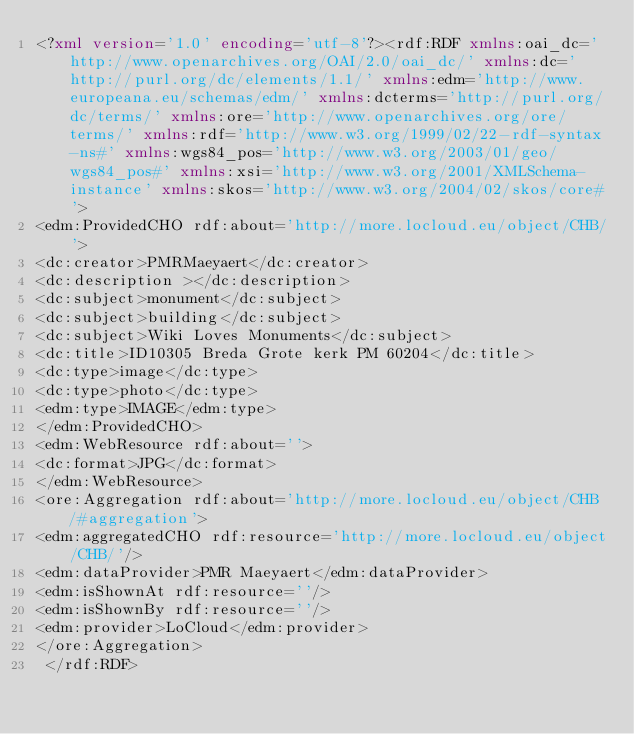Convert code to text. <code><loc_0><loc_0><loc_500><loc_500><_XML_><?xml version='1.0' encoding='utf-8'?><rdf:RDF xmlns:oai_dc='http://www.openarchives.org/OAI/2.0/oai_dc/' xmlns:dc='http://purl.org/dc/elements/1.1/' xmlns:edm='http://www.europeana.eu/schemas/edm/' xmlns:dcterms='http://purl.org/dc/terms/' xmlns:ore='http://www.openarchives.org/ore/terms/' xmlns:rdf='http://www.w3.org/1999/02/22-rdf-syntax-ns#' xmlns:wgs84_pos='http://www.w3.org/2003/01/geo/wgs84_pos#' xmlns:xsi='http://www.w3.org/2001/XMLSchema-instance' xmlns:skos='http://www.w3.org/2004/02/skos/core#'>
<edm:ProvidedCHO rdf:about='http://more.locloud.eu/object/CHB/'>
<dc:creator>PMRMaeyaert</dc:creator>
<dc:description ></dc:description>
<dc:subject>monument</dc:subject>
<dc:subject>building</dc:subject>
<dc:subject>Wiki Loves Monuments</dc:subject>
<dc:title>ID10305 Breda Grote kerk PM 60204</dc:title>
<dc:type>image</dc:type>
<dc:type>photo</dc:type>
<edm:type>IMAGE</edm:type>
</edm:ProvidedCHO>
<edm:WebResource rdf:about=''>
<dc:format>JPG</dc:format>
</edm:WebResource>
<ore:Aggregation rdf:about='http://more.locloud.eu/object/CHB/#aggregation'>
<edm:aggregatedCHO rdf:resource='http://more.locloud.eu/object/CHB/'/>
<edm:dataProvider>PMR Maeyaert</edm:dataProvider>
<edm:isShownAt rdf:resource=''/>
<edm:isShownBy rdf:resource=''/>
<edm:provider>LoCloud</edm:provider>
</ore:Aggregation>
 </rdf:RDF>
</code> 